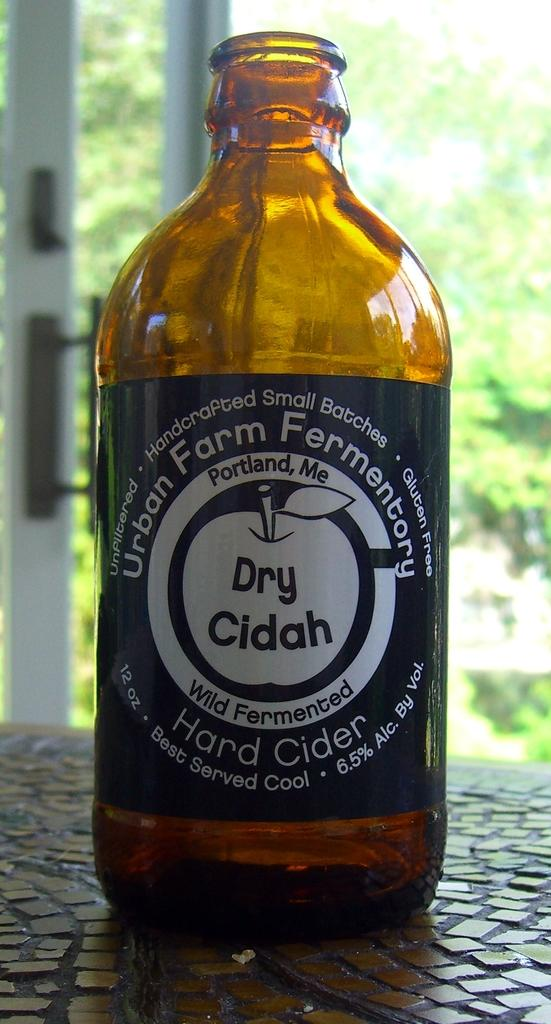<image>
Give a short and clear explanation of the subsequent image. An empty bottle of Urban Farms dry cider. 